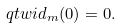<formula> <loc_0><loc_0><loc_500><loc_500>\ q t w i d _ { m } ( 0 ) = 0 .</formula> 